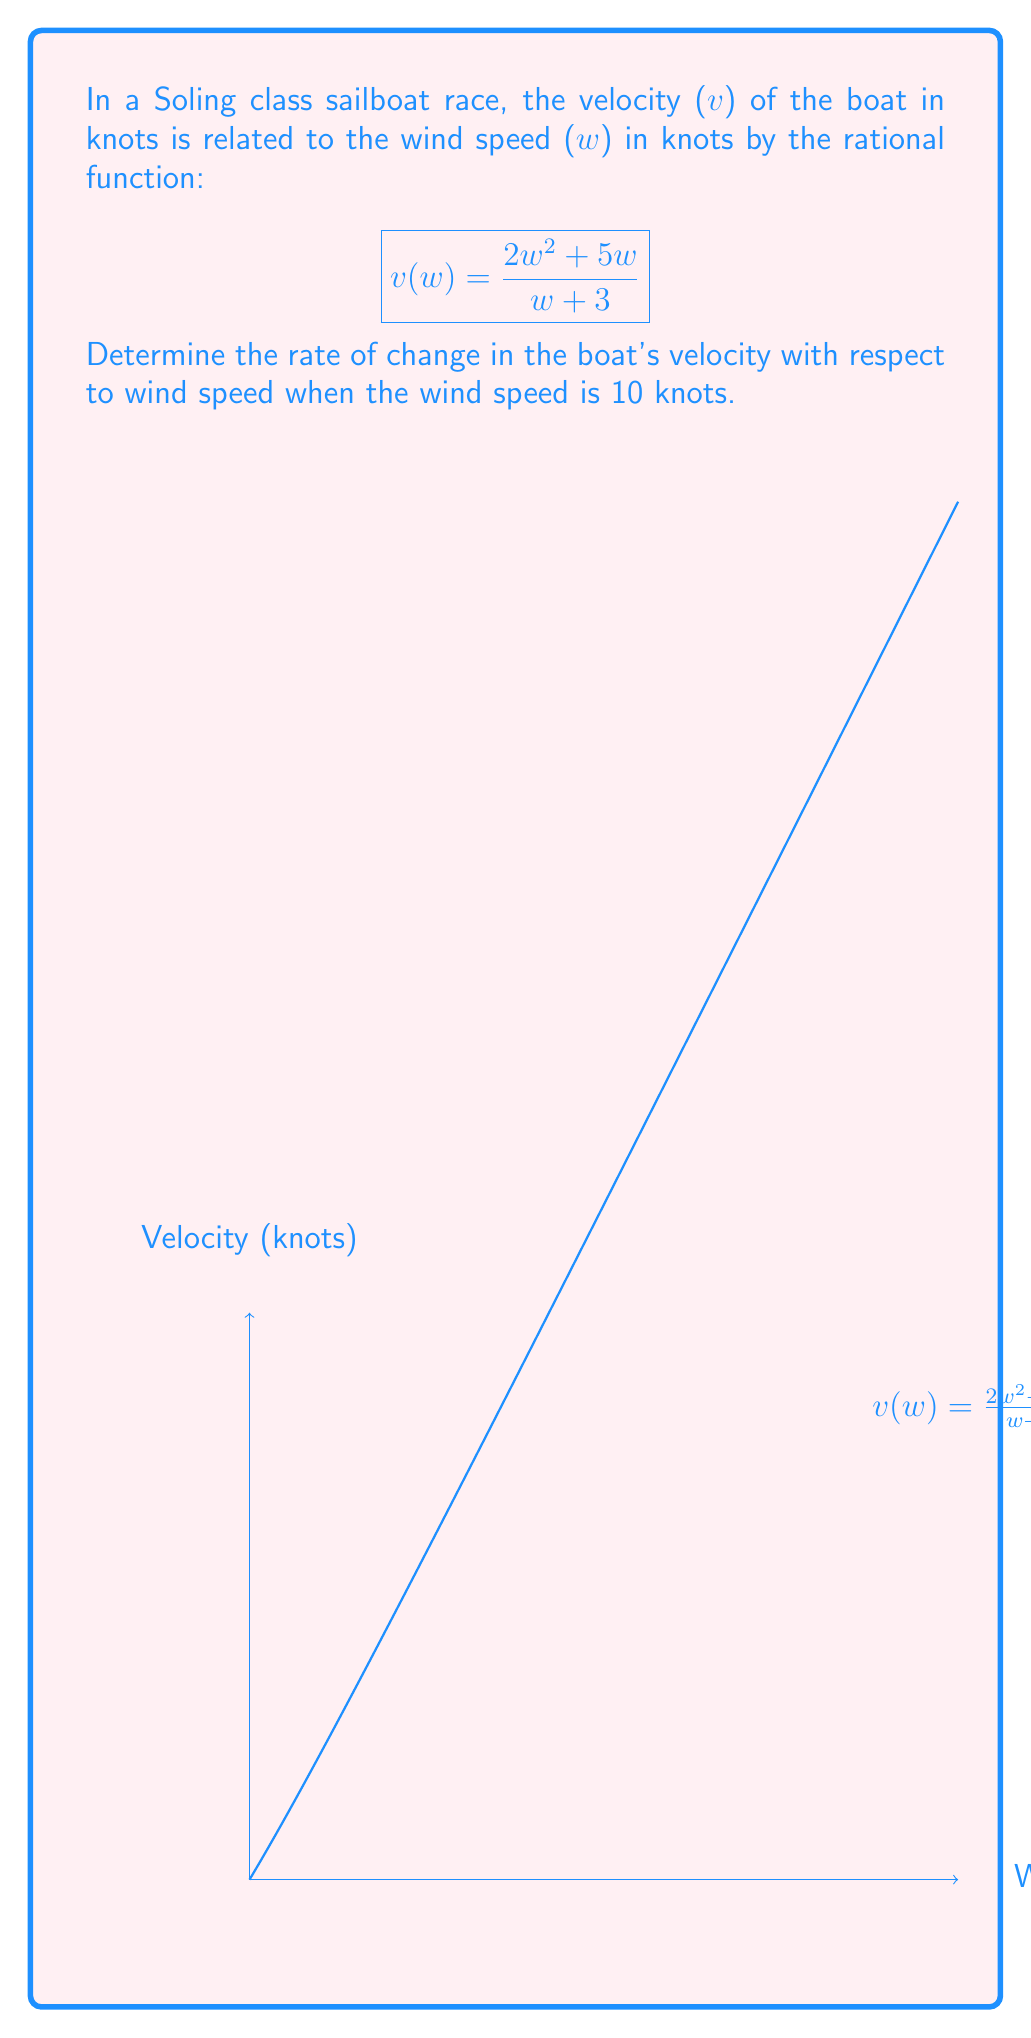Can you answer this question? To find the rate of change in the boat's velocity with respect to wind speed, we need to find the derivative of the given function $v(w)$ and then evaluate it at $w = 10$.

Step 1: Calculate the derivative of $v(w)$ using the quotient rule.
Let $u = 2w^2 + 5w$ and $v = w + 3$
$$\frac{d}{dw}v(w) = \frac{d}{dw}\left(\frac{u}{v}\right) = \frac{v\frac{du}{dw} - u\frac{dv}{dw}}{v^2}$$

Step 2: Calculate $\frac{du}{dw}$ and $\frac{dv}{dw}$
$\frac{du}{dw} = 4w + 5$
$\frac{dv}{dw} = 1$

Step 3: Substitute into the quotient rule formula
$$\frac{d}{dw}v(w) = \frac{(w+3)(4w+5) - (2w^2+5w)(1)}{(w+3)^2}$$

Step 4: Simplify the numerator
$$\frac{d}{dw}v(w) = \frac{4w^2+12w+5w+15 - 2w^2-5w}{(w+3)^2} = \frac{2w^2+12w+15}{(w+3)^2}$$

Step 5: Evaluate the derivative at $w = 10$
$$\frac{d}{dw}v(10) = \frac{2(10)^2+12(10)+15}{(10+3)^2} = \frac{200+120+15}{13^2} = \frac{335}{169}$$

Therefore, the rate of change in the boat's velocity with respect to wind speed when the wind speed is 10 knots is $\frac{335}{169}$ knots per knot of wind speed.
Answer: $\frac{335}{169}$ knots per knot 